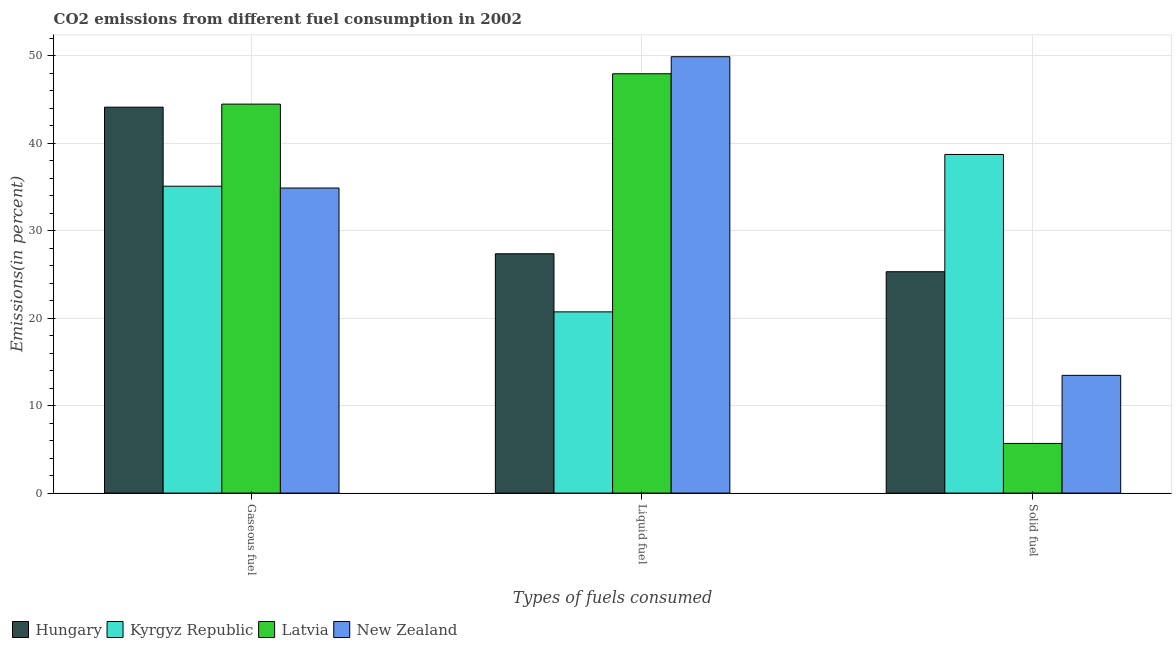How many different coloured bars are there?
Keep it short and to the point. 4. How many bars are there on the 2nd tick from the right?
Keep it short and to the point. 4. What is the label of the 3rd group of bars from the left?
Keep it short and to the point. Solid fuel. What is the percentage of liquid fuel emission in Latvia?
Your answer should be very brief. 47.96. Across all countries, what is the maximum percentage of gaseous fuel emission?
Make the answer very short. 44.49. Across all countries, what is the minimum percentage of liquid fuel emission?
Provide a succinct answer. 20.73. In which country was the percentage of solid fuel emission maximum?
Your answer should be very brief. Kyrgyz Republic. In which country was the percentage of gaseous fuel emission minimum?
Ensure brevity in your answer.  New Zealand. What is the total percentage of gaseous fuel emission in the graph?
Give a very brief answer. 158.62. What is the difference between the percentage of gaseous fuel emission in Kyrgyz Republic and that in Latvia?
Make the answer very short. -9.39. What is the difference between the percentage of gaseous fuel emission in New Zealand and the percentage of liquid fuel emission in Latvia?
Your answer should be compact. -13.07. What is the average percentage of liquid fuel emission per country?
Your answer should be very brief. 36.49. What is the difference between the percentage of solid fuel emission and percentage of gaseous fuel emission in Latvia?
Give a very brief answer. -38.81. What is the ratio of the percentage of liquid fuel emission in Latvia to that in Kyrgyz Republic?
Your answer should be very brief. 2.31. Is the percentage of solid fuel emission in Latvia less than that in Hungary?
Give a very brief answer. Yes. Is the difference between the percentage of solid fuel emission in Hungary and Latvia greater than the difference between the percentage of liquid fuel emission in Hungary and Latvia?
Your response must be concise. Yes. What is the difference between the highest and the second highest percentage of liquid fuel emission?
Provide a short and direct response. 1.95. What is the difference between the highest and the lowest percentage of solid fuel emission?
Provide a succinct answer. 33.05. What does the 1st bar from the left in Liquid fuel represents?
Provide a short and direct response. Hungary. What does the 1st bar from the right in Gaseous fuel represents?
Keep it short and to the point. New Zealand. Is it the case that in every country, the sum of the percentage of gaseous fuel emission and percentage of liquid fuel emission is greater than the percentage of solid fuel emission?
Offer a very short reply. Yes. Are all the bars in the graph horizontal?
Ensure brevity in your answer.  No. How many countries are there in the graph?
Provide a succinct answer. 4. Does the graph contain any zero values?
Your answer should be compact. No. How are the legend labels stacked?
Offer a very short reply. Horizontal. What is the title of the graph?
Offer a terse response. CO2 emissions from different fuel consumption in 2002. What is the label or title of the X-axis?
Give a very brief answer. Types of fuels consumed. What is the label or title of the Y-axis?
Give a very brief answer. Emissions(in percent). What is the Emissions(in percent) in Hungary in Gaseous fuel?
Make the answer very short. 44.14. What is the Emissions(in percent) of Kyrgyz Republic in Gaseous fuel?
Your response must be concise. 35.1. What is the Emissions(in percent) in Latvia in Gaseous fuel?
Provide a short and direct response. 44.49. What is the Emissions(in percent) of New Zealand in Gaseous fuel?
Give a very brief answer. 34.89. What is the Emissions(in percent) of Hungary in Liquid fuel?
Ensure brevity in your answer.  27.37. What is the Emissions(in percent) in Kyrgyz Republic in Liquid fuel?
Provide a short and direct response. 20.73. What is the Emissions(in percent) in Latvia in Liquid fuel?
Keep it short and to the point. 47.96. What is the Emissions(in percent) in New Zealand in Liquid fuel?
Keep it short and to the point. 49.91. What is the Emissions(in percent) in Hungary in Solid fuel?
Keep it short and to the point. 25.32. What is the Emissions(in percent) in Kyrgyz Republic in Solid fuel?
Give a very brief answer. 38.73. What is the Emissions(in percent) in Latvia in Solid fuel?
Offer a terse response. 5.68. What is the Emissions(in percent) in New Zealand in Solid fuel?
Provide a short and direct response. 13.46. Across all Types of fuels consumed, what is the maximum Emissions(in percent) in Hungary?
Give a very brief answer. 44.14. Across all Types of fuels consumed, what is the maximum Emissions(in percent) in Kyrgyz Republic?
Your answer should be compact. 38.73. Across all Types of fuels consumed, what is the maximum Emissions(in percent) in Latvia?
Make the answer very short. 47.96. Across all Types of fuels consumed, what is the maximum Emissions(in percent) in New Zealand?
Offer a very short reply. 49.91. Across all Types of fuels consumed, what is the minimum Emissions(in percent) of Hungary?
Offer a terse response. 25.32. Across all Types of fuels consumed, what is the minimum Emissions(in percent) in Kyrgyz Republic?
Keep it short and to the point. 20.73. Across all Types of fuels consumed, what is the minimum Emissions(in percent) of Latvia?
Offer a terse response. 5.68. Across all Types of fuels consumed, what is the minimum Emissions(in percent) in New Zealand?
Give a very brief answer. 13.46. What is the total Emissions(in percent) in Hungary in the graph?
Give a very brief answer. 96.83. What is the total Emissions(in percent) of Kyrgyz Republic in the graph?
Ensure brevity in your answer.  94.55. What is the total Emissions(in percent) of Latvia in the graph?
Ensure brevity in your answer.  98.13. What is the total Emissions(in percent) in New Zealand in the graph?
Ensure brevity in your answer.  98.27. What is the difference between the Emissions(in percent) in Hungary in Gaseous fuel and that in Liquid fuel?
Ensure brevity in your answer.  16.77. What is the difference between the Emissions(in percent) of Kyrgyz Republic in Gaseous fuel and that in Liquid fuel?
Keep it short and to the point. 14.37. What is the difference between the Emissions(in percent) in Latvia in Gaseous fuel and that in Liquid fuel?
Provide a succinct answer. -3.47. What is the difference between the Emissions(in percent) in New Zealand in Gaseous fuel and that in Liquid fuel?
Your answer should be very brief. -15.02. What is the difference between the Emissions(in percent) in Hungary in Gaseous fuel and that in Solid fuel?
Keep it short and to the point. 18.82. What is the difference between the Emissions(in percent) of Kyrgyz Republic in Gaseous fuel and that in Solid fuel?
Your response must be concise. -3.63. What is the difference between the Emissions(in percent) of Latvia in Gaseous fuel and that in Solid fuel?
Provide a succinct answer. 38.81. What is the difference between the Emissions(in percent) of New Zealand in Gaseous fuel and that in Solid fuel?
Provide a succinct answer. 21.43. What is the difference between the Emissions(in percent) of Hungary in Liquid fuel and that in Solid fuel?
Ensure brevity in your answer.  2.05. What is the difference between the Emissions(in percent) of Kyrgyz Republic in Liquid fuel and that in Solid fuel?
Make the answer very short. -18. What is the difference between the Emissions(in percent) in Latvia in Liquid fuel and that in Solid fuel?
Keep it short and to the point. 42.28. What is the difference between the Emissions(in percent) in New Zealand in Liquid fuel and that in Solid fuel?
Provide a short and direct response. 36.45. What is the difference between the Emissions(in percent) in Hungary in Gaseous fuel and the Emissions(in percent) in Kyrgyz Republic in Liquid fuel?
Your response must be concise. 23.41. What is the difference between the Emissions(in percent) of Hungary in Gaseous fuel and the Emissions(in percent) of Latvia in Liquid fuel?
Offer a terse response. -3.82. What is the difference between the Emissions(in percent) of Hungary in Gaseous fuel and the Emissions(in percent) of New Zealand in Liquid fuel?
Provide a short and direct response. -5.77. What is the difference between the Emissions(in percent) in Kyrgyz Republic in Gaseous fuel and the Emissions(in percent) in Latvia in Liquid fuel?
Give a very brief answer. -12.86. What is the difference between the Emissions(in percent) in Kyrgyz Republic in Gaseous fuel and the Emissions(in percent) in New Zealand in Liquid fuel?
Your answer should be compact. -14.81. What is the difference between the Emissions(in percent) in Latvia in Gaseous fuel and the Emissions(in percent) in New Zealand in Liquid fuel?
Provide a short and direct response. -5.42. What is the difference between the Emissions(in percent) in Hungary in Gaseous fuel and the Emissions(in percent) in Kyrgyz Republic in Solid fuel?
Give a very brief answer. 5.41. What is the difference between the Emissions(in percent) of Hungary in Gaseous fuel and the Emissions(in percent) of Latvia in Solid fuel?
Your response must be concise. 38.46. What is the difference between the Emissions(in percent) in Hungary in Gaseous fuel and the Emissions(in percent) in New Zealand in Solid fuel?
Give a very brief answer. 30.68. What is the difference between the Emissions(in percent) of Kyrgyz Republic in Gaseous fuel and the Emissions(in percent) of Latvia in Solid fuel?
Give a very brief answer. 29.42. What is the difference between the Emissions(in percent) of Kyrgyz Republic in Gaseous fuel and the Emissions(in percent) of New Zealand in Solid fuel?
Give a very brief answer. 21.63. What is the difference between the Emissions(in percent) of Latvia in Gaseous fuel and the Emissions(in percent) of New Zealand in Solid fuel?
Your answer should be very brief. 31.02. What is the difference between the Emissions(in percent) in Hungary in Liquid fuel and the Emissions(in percent) in Kyrgyz Republic in Solid fuel?
Your response must be concise. -11.36. What is the difference between the Emissions(in percent) of Hungary in Liquid fuel and the Emissions(in percent) of Latvia in Solid fuel?
Your answer should be very brief. 21.69. What is the difference between the Emissions(in percent) in Hungary in Liquid fuel and the Emissions(in percent) in New Zealand in Solid fuel?
Provide a short and direct response. 13.91. What is the difference between the Emissions(in percent) of Kyrgyz Republic in Liquid fuel and the Emissions(in percent) of Latvia in Solid fuel?
Make the answer very short. 15.05. What is the difference between the Emissions(in percent) of Kyrgyz Republic in Liquid fuel and the Emissions(in percent) of New Zealand in Solid fuel?
Give a very brief answer. 7.26. What is the difference between the Emissions(in percent) of Latvia in Liquid fuel and the Emissions(in percent) of New Zealand in Solid fuel?
Make the answer very short. 34.5. What is the average Emissions(in percent) in Hungary per Types of fuels consumed?
Keep it short and to the point. 32.28. What is the average Emissions(in percent) in Kyrgyz Republic per Types of fuels consumed?
Offer a terse response. 31.52. What is the average Emissions(in percent) of Latvia per Types of fuels consumed?
Offer a very short reply. 32.71. What is the average Emissions(in percent) of New Zealand per Types of fuels consumed?
Provide a succinct answer. 32.76. What is the difference between the Emissions(in percent) in Hungary and Emissions(in percent) in Kyrgyz Republic in Gaseous fuel?
Ensure brevity in your answer.  9.04. What is the difference between the Emissions(in percent) of Hungary and Emissions(in percent) of Latvia in Gaseous fuel?
Offer a terse response. -0.35. What is the difference between the Emissions(in percent) in Hungary and Emissions(in percent) in New Zealand in Gaseous fuel?
Ensure brevity in your answer.  9.25. What is the difference between the Emissions(in percent) of Kyrgyz Republic and Emissions(in percent) of Latvia in Gaseous fuel?
Give a very brief answer. -9.39. What is the difference between the Emissions(in percent) of Kyrgyz Republic and Emissions(in percent) of New Zealand in Gaseous fuel?
Provide a succinct answer. 0.21. What is the difference between the Emissions(in percent) in Latvia and Emissions(in percent) in New Zealand in Gaseous fuel?
Keep it short and to the point. 9.6. What is the difference between the Emissions(in percent) in Hungary and Emissions(in percent) in Kyrgyz Republic in Liquid fuel?
Give a very brief answer. 6.65. What is the difference between the Emissions(in percent) of Hungary and Emissions(in percent) of Latvia in Liquid fuel?
Give a very brief answer. -20.59. What is the difference between the Emissions(in percent) in Hungary and Emissions(in percent) in New Zealand in Liquid fuel?
Provide a succinct answer. -22.54. What is the difference between the Emissions(in percent) of Kyrgyz Republic and Emissions(in percent) of Latvia in Liquid fuel?
Keep it short and to the point. -27.23. What is the difference between the Emissions(in percent) of Kyrgyz Republic and Emissions(in percent) of New Zealand in Liquid fuel?
Offer a very short reply. -29.19. What is the difference between the Emissions(in percent) in Latvia and Emissions(in percent) in New Zealand in Liquid fuel?
Ensure brevity in your answer.  -1.95. What is the difference between the Emissions(in percent) of Hungary and Emissions(in percent) of Kyrgyz Republic in Solid fuel?
Your response must be concise. -13.41. What is the difference between the Emissions(in percent) of Hungary and Emissions(in percent) of Latvia in Solid fuel?
Give a very brief answer. 19.64. What is the difference between the Emissions(in percent) of Hungary and Emissions(in percent) of New Zealand in Solid fuel?
Make the answer very short. 11.86. What is the difference between the Emissions(in percent) of Kyrgyz Republic and Emissions(in percent) of Latvia in Solid fuel?
Offer a terse response. 33.05. What is the difference between the Emissions(in percent) in Kyrgyz Republic and Emissions(in percent) in New Zealand in Solid fuel?
Make the answer very short. 25.27. What is the difference between the Emissions(in percent) in Latvia and Emissions(in percent) in New Zealand in Solid fuel?
Provide a succinct answer. -7.79. What is the ratio of the Emissions(in percent) in Hungary in Gaseous fuel to that in Liquid fuel?
Offer a terse response. 1.61. What is the ratio of the Emissions(in percent) in Kyrgyz Republic in Gaseous fuel to that in Liquid fuel?
Ensure brevity in your answer.  1.69. What is the ratio of the Emissions(in percent) in Latvia in Gaseous fuel to that in Liquid fuel?
Ensure brevity in your answer.  0.93. What is the ratio of the Emissions(in percent) in New Zealand in Gaseous fuel to that in Liquid fuel?
Your response must be concise. 0.7. What is the ratio of the Emissions(in percent) of Hungary in Gaseous fuel to that in Solid fuel?
Provide a short and direct response. 1.74. What is the ratio of the Emissions(in percent) in Kyrgyz Republic in Gaseous fuel to that in Solid fuel?
Your answer should be very brief. 0.91. What is the ratio of the Emissions(in percent) of Latvia in Gaseous fuel to that in Solid fuel?
Your answer should be compact. 7.83. What is the ratio of the Emissions(in percent) in New Zealand in Gaseous fuel to that in Solid fuel?
Offer a very short reply. 2.59. What is the ratio of the Emissions(in percent) of Hungary in Liquid fuel to that in Solid fuel?
Your answer should be very brief. 1.08. What is the ratio of the Emissions(in percent) of Kyrgyz Republic in Liquid fuel to that in Solid fuel?
Offer a very short reply. 0.54. What is the ratio of the Emissions(in percent) in Latvia in Liquid fuel to that in Solid fuel?
Ensure brevity in your answer.  8.45. What is the ratio of the Emissions(in percent) in New Zealand in Liquid fuel to that in Solid fuel?
Your answer should be very brief. 3.71. What is the difference between the highest and the second highest Emissions(in percent) of Hungary?
Provide a succinct answer. 16.77. What is the difference between the highest and the second highest Emissions(in percent) in Kyrgyz Republic?
Provide a succinct answer. 3.63. What is the difference between the highest and the second highest Emissions(in percent) in Latvia?
Your answer should be very brief. 3.47. What is the difference between the highest and the second highest Emissions(in percent) of New Zealand?
Give a very brief answer. 15.02. What is the difference between the highest and the lowest Emissions(in percent) of Hungary?
Your answer should be very brief. 18.82. What is the difference between the highest and the lowest Emissions(in percent) in Kyrgyz Republic?
Provide a short and direct response. 18. What is the difference between the highest and the lowest Emissions(in percent) of Latvia?
Make the answer very short. 42.28. What is the difference between the highest and the lowest Emissions(in percent) in New Zealand?
Provide a short and direct response. 36.45. 